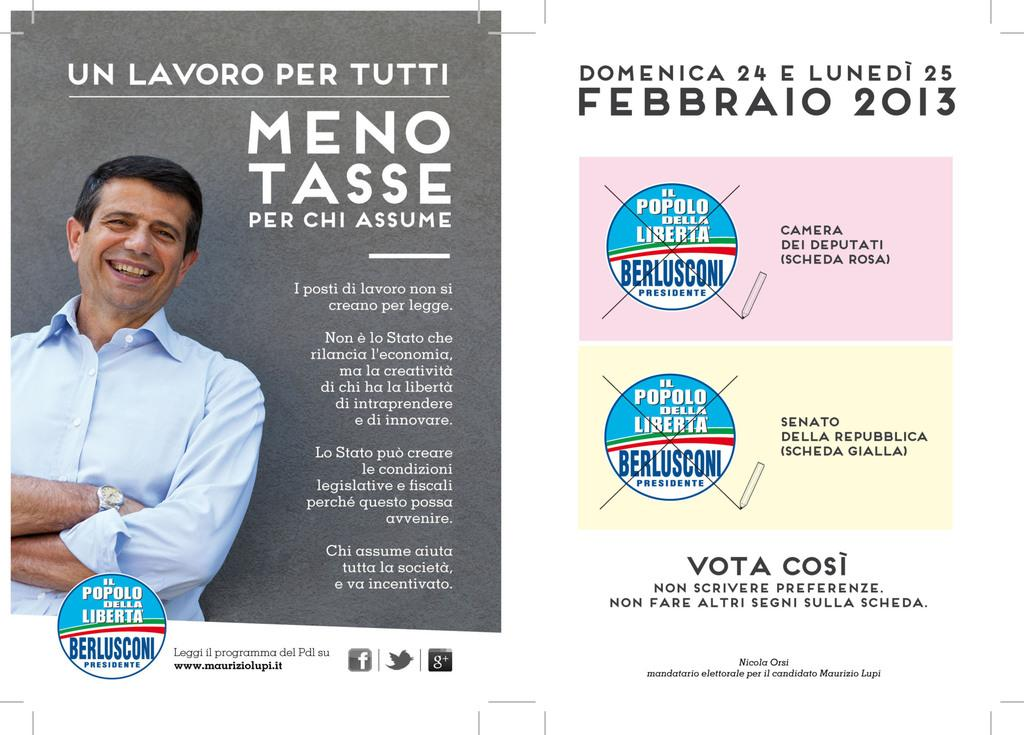Who is on the left side of the image? There is a man on the left side of the image. What is the man doing in the image? The man is smiling in the image. What can be seen on the left side of the image besides the man? There are texts written on the image on the left side. What can be seen on the right side of the image? There are texts written on the image on the right side. What type of sweater is the man wearing in the image? The image does not show the man wearing a sweater, so it cannot be determined from the image. 